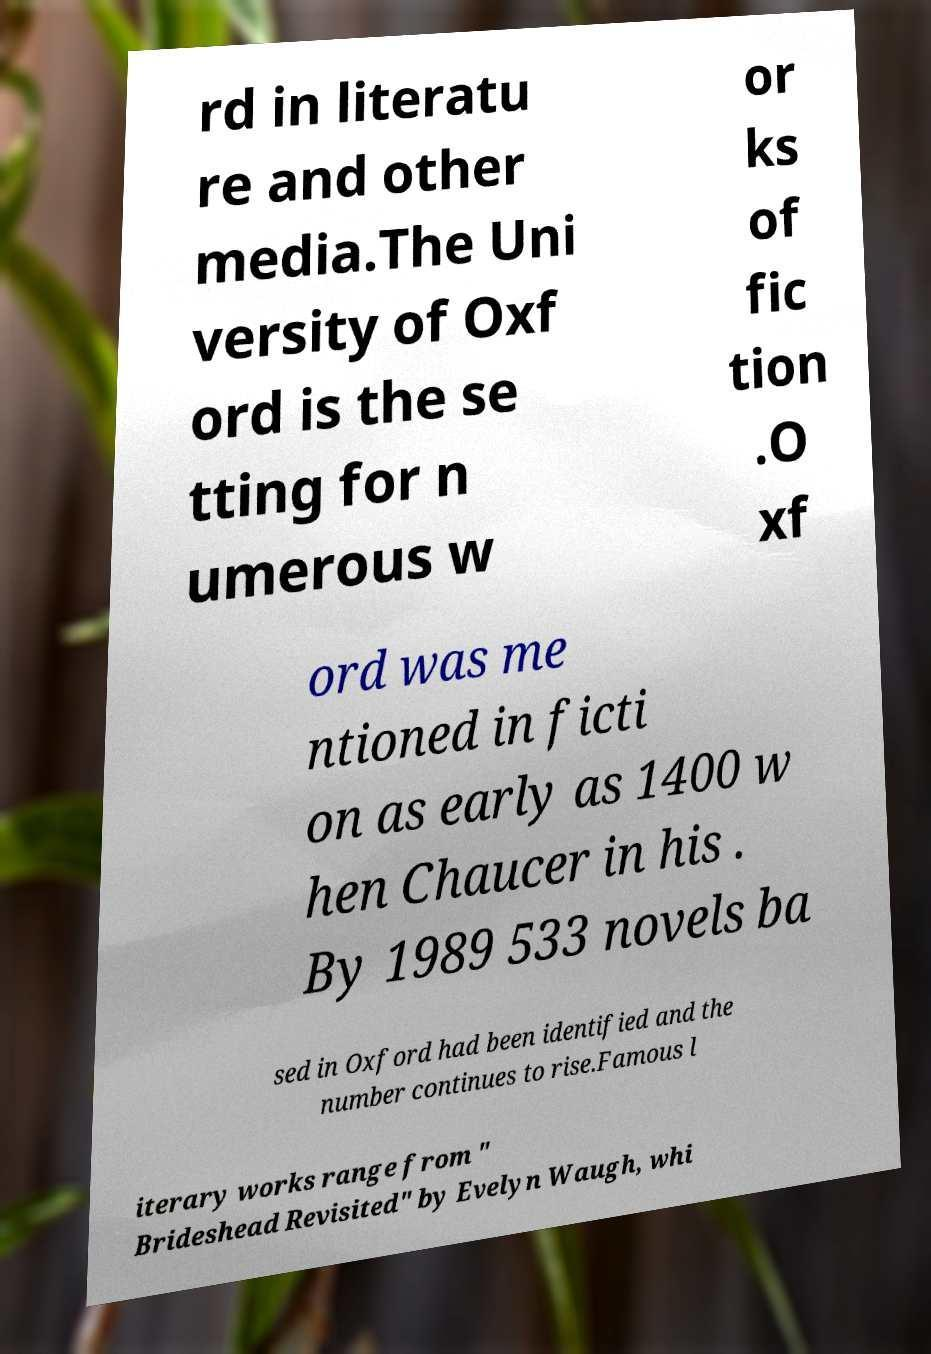For documentation purposes, I need the text within this image transcribed. Could you provide that? rd in literatu re and other media.The Uni versity of Oxf ord is the se tting for n umerous w or ks of fic tion .O xf ord was me ntioned in ficti on as early as 1400 w hen Chaucer in his . By 1989 533 novels ba sed in Oxford had been identified and the number continues to rise.Famous l iterary works range from " Brideshead Revisited" by Evelyn Waugh, whi 